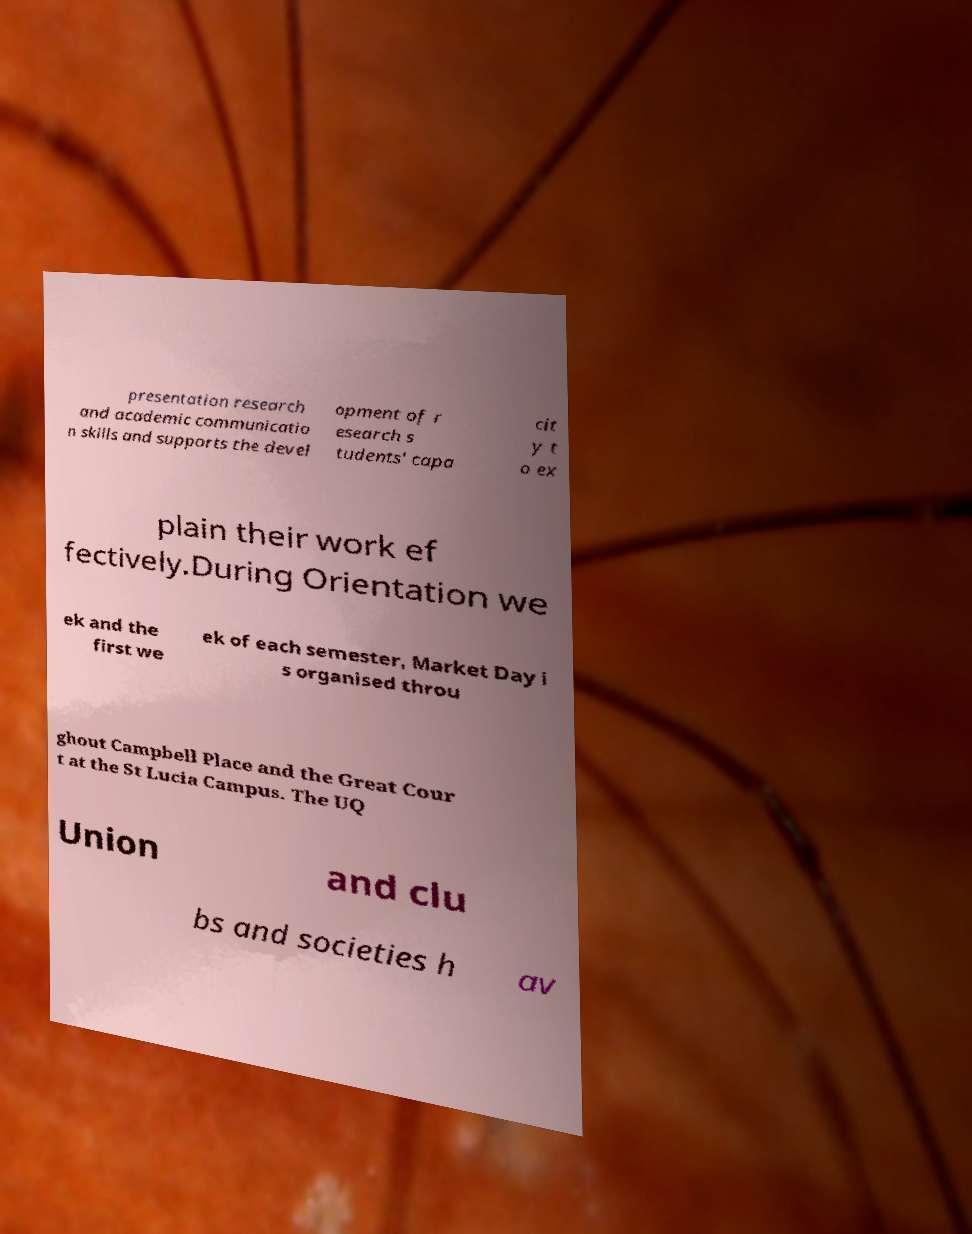I need the written content from this picture converted into text. Can you do that? presentation research and academic communicatio n skills and supports the devel opment of r esearch s tudents' capa cit y t o ex plain their work ef fectively.During Orientation we ek and the first we ek of each semester, Market Day i s organised throu ghout Campbell Place and the Great Cour t at the St Lucia Campus. The UQ Union and clu bs and societies h av 